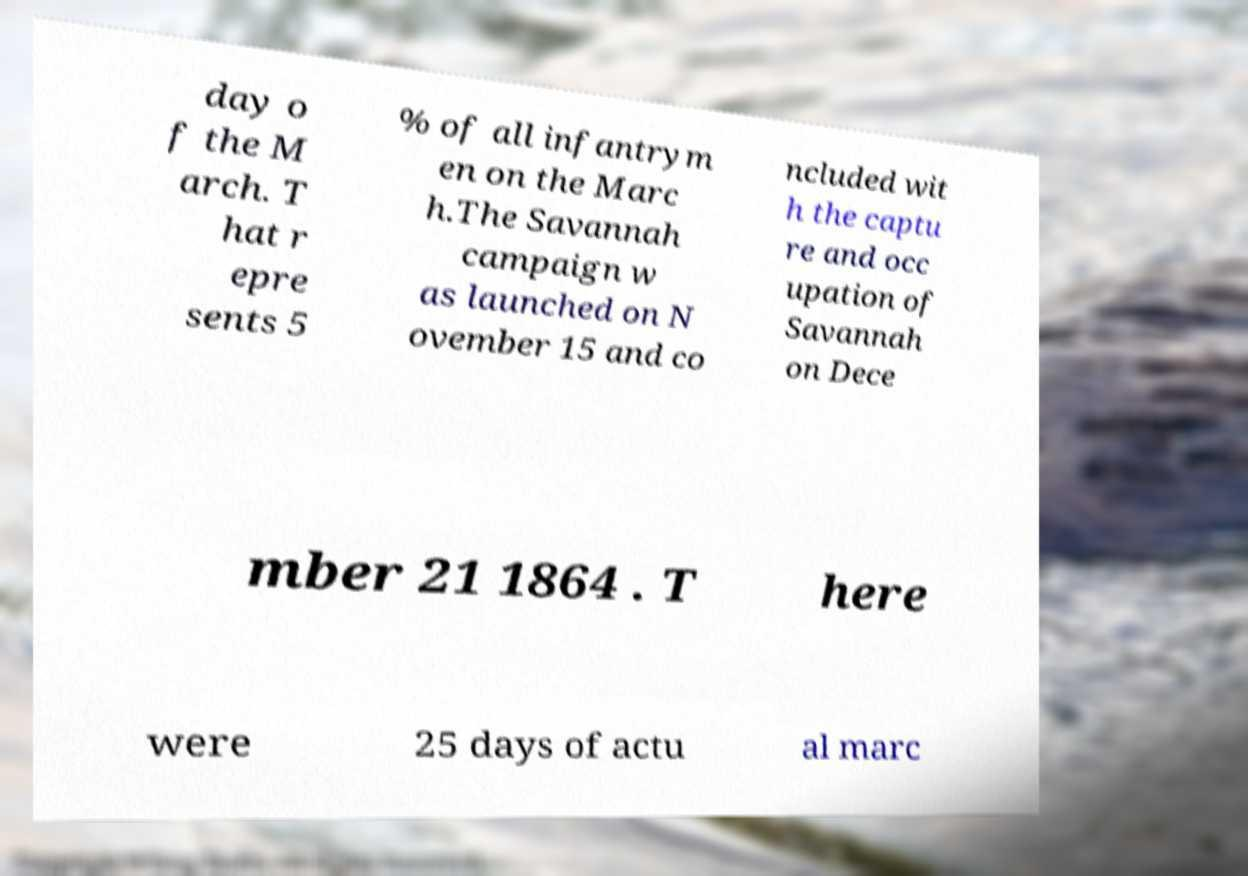What messages or text are displayed in this image? I need them in a readable, typed format. day o f the M arch. T hat r epre sents 5 % of all infantrym en on the Marc h.The Savannah campaign w as launched on N ovember 15 and co ncluded wit h the captu re and occ upation of Savannah on Dece mber 21 1864 . T here were 25 days of actu al marc 